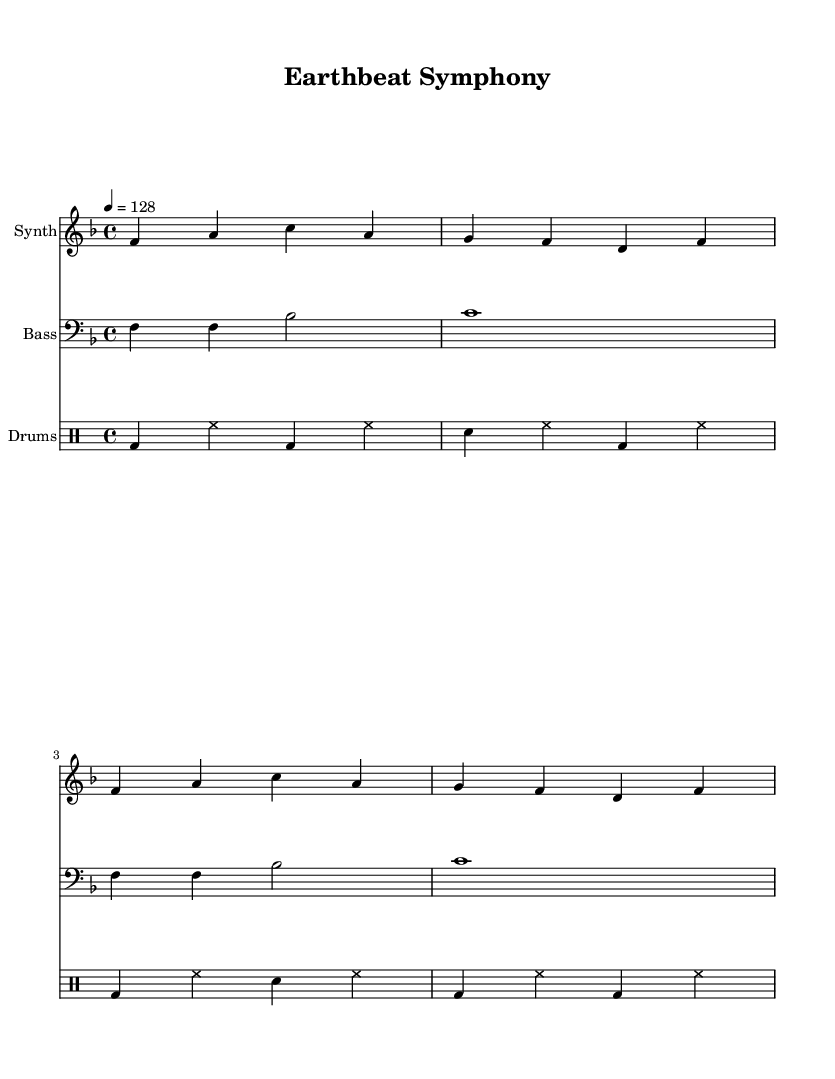What is the key signature of this music? The key signature is F major, which has one flat (B flat). This can be determined by looking at the beginning of the staff where the flat is indicated.
Answer: F major What is the time signature of this music? The time signature is 4/4. This is observed at the beginning of the music, indicating four beats per measure with a quarter note getting one beat.
Answer: 4/4 What is the tempo marking for this piece? The tempo marking is 128 beats per minute. This is indicated in the music with the tempo notation of ‘4 = 128’ at the beginning.
Answer: 128 How many measures are in the synth part? There are four measures in the synth part. By counting the number of vertical lines separating the notes in the synth staff, we see there are four distinct groupings.
Answer: 4 What type of drum is indicated first in the drum part? The first drum type indicated in the drum part is bass drum. This is evident from the notation in the first measure, where "bd" represents the bass drum.
Answer: bass drum What is the highest note played by the synth? The highest note played by the synth is C. Looking at the notes in the synth staff, the C note is the highest pitch appearing in the notation.
Answer: C How many different instruments are represented in the score? There are three different instruments represented in the score: Synth, Bass, and Drums. This can be identified from the labels at the beginning of each staff.
Answer: 3 